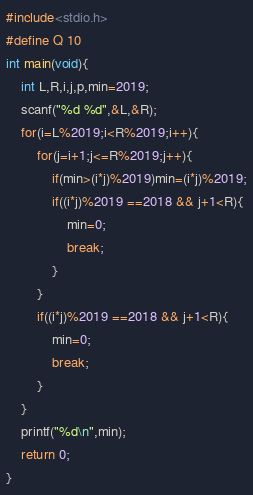<code> <loc_0><loc_0><loc_500><loc_500><_C_>#include<stdio.h>
#define Q 10
int main(void){
    int L,R,i,j,p,min=2019;
    scanf("%d %d",&L,&R);
    for(i=L%2019;i<R%2019;i++){
        for(j=i+1;j<=R%2019;j++){
            if(min>(i*j)%2019)min=(i*j)%2019;
            if((i*j)%2019 ==2018 && j+1<R){
                min=0;
                break;
            }
        }
        if((i*j)%2019 ==2018 && j+1<R){
            min=0;
            break;
        }
    }
    printf("%d\n",min);
    return 0;
}</code> 